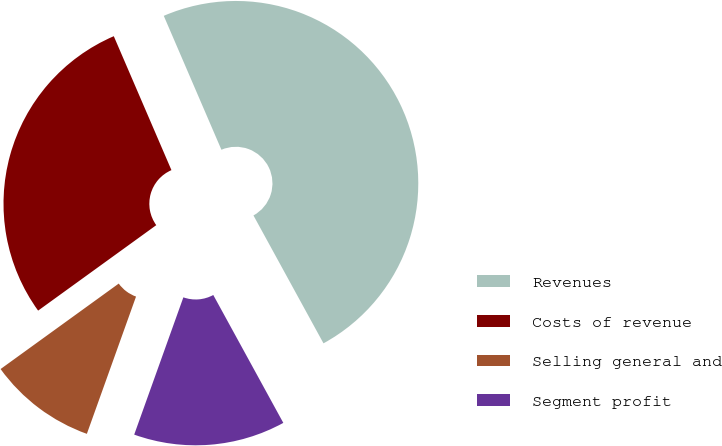Convert chart to OTSL. <chart><loc_0><loc_0><loc_500><loc_500><pie_chart><fcel>Revenues<fcel>Costs of revenue<fcel>Selling general and<fcel>Segment profit<nl><fcel>48.5%<fcel>28.5%<fcel>9.56%<fcel>13.45%<nl></chart> 